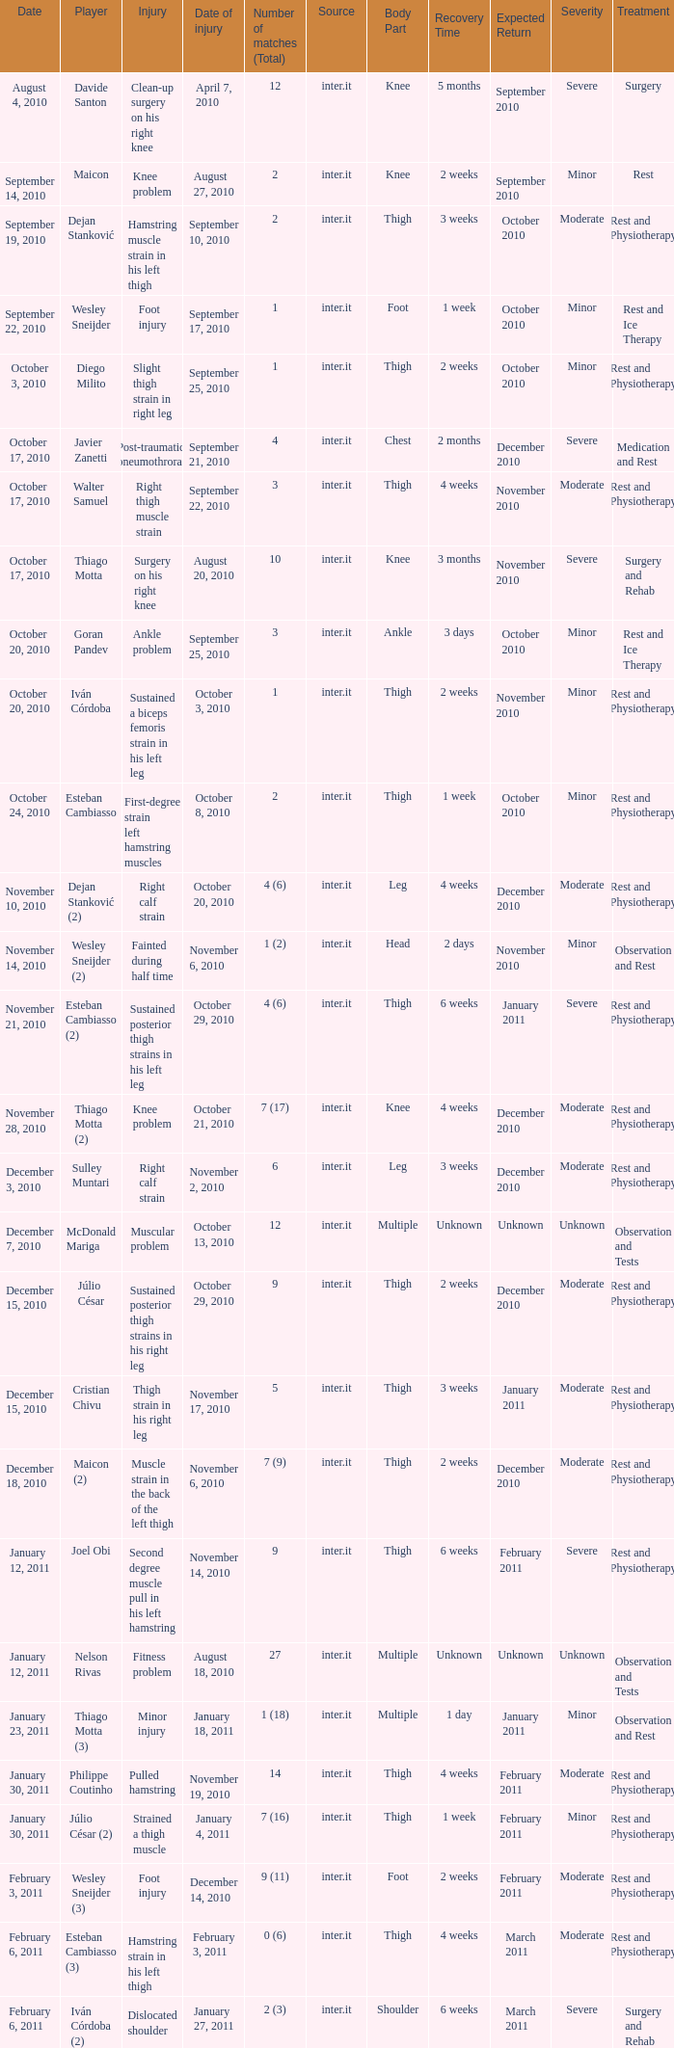How many times was the date october 3, 2010? 1.0. 